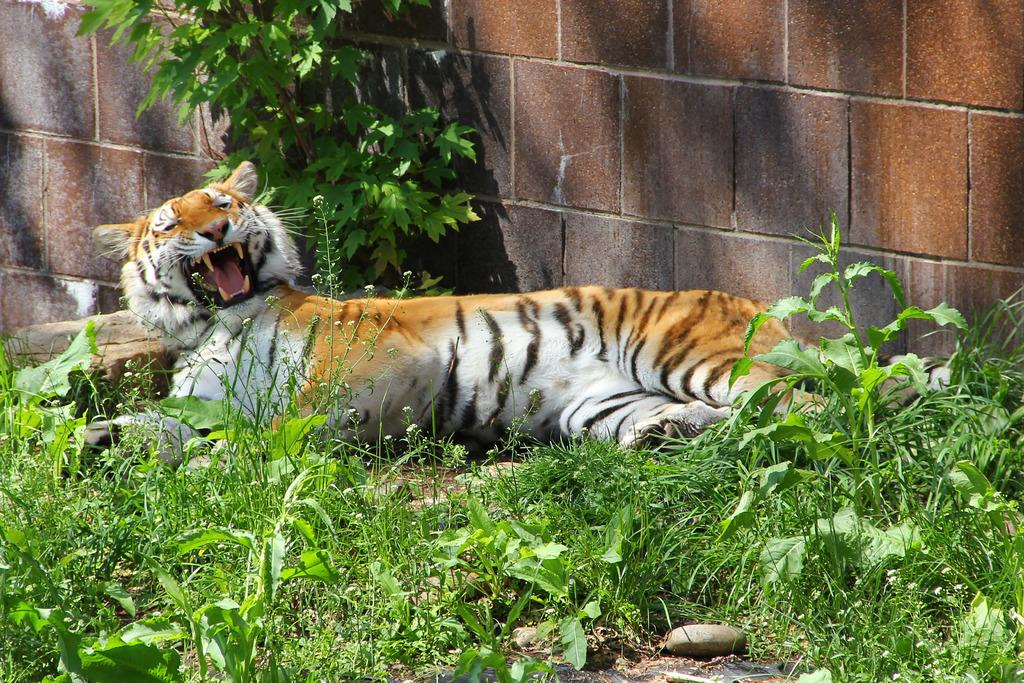What type of living organisms can be seen in the image? Plants can be seen in the image. What animal is present in the image? There is a tiger in the image. What is located beside the tiger in the image? There is a wall beside the tiger in the image. What type of roof can be seen above the tiger in the image? There is no roof visible in the image; only a wall is present beside the tiger. What kind of feast is being prepared in the image? There is no feast or any indication of food preparation in the image. 